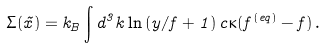Convert formula to latex. <formula><loc_0><loc_0><loc_500><loc_500>\Sigma ( \vec { x } ) = k _ { B } \int d ^ { 3 } k \ln \left ( y / f + 1 \right ) c \kappa ( f ^ { ( e q ) } - f ) \, .</formula> 